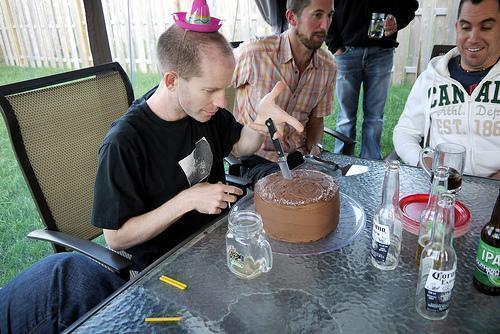How many people are at the table?
Give a very brief answer. 3. 